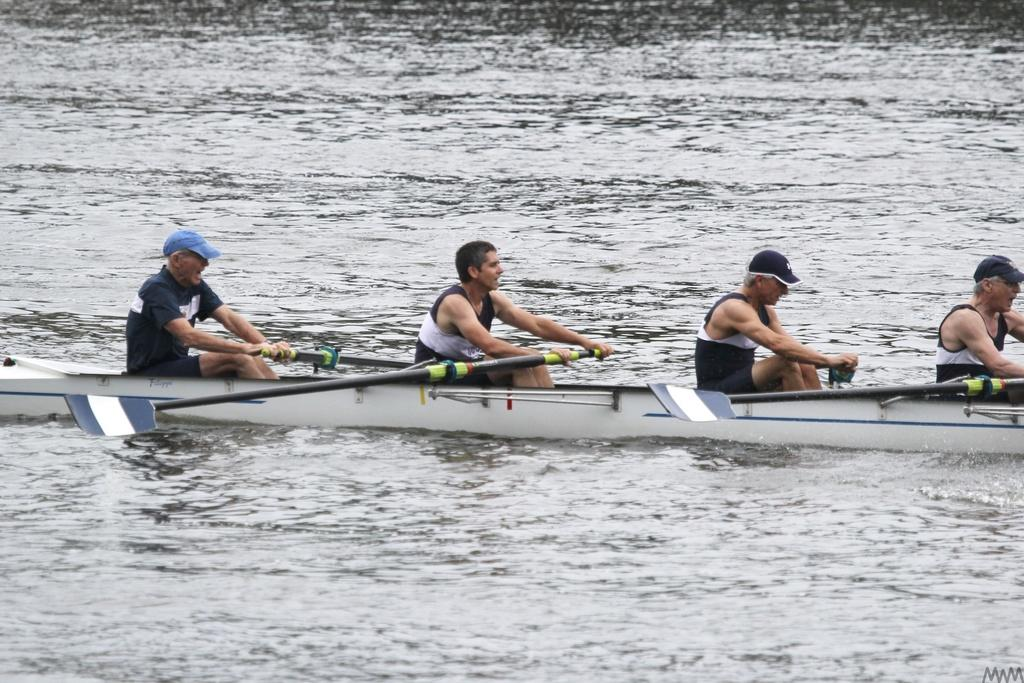What are the people in the image doing? The people in the image are sitting on a boat. What are the people holding in their hands? The people are holding objects in their hands. What is used to propel the boat in the image? Oars are attached to the boat. What type of headwear can be seen on some of the people in the image? Some of the people are wearing caps. What is the profit made by the cats in the image? There are no cats present in the image, so there is no profit to discuss. 